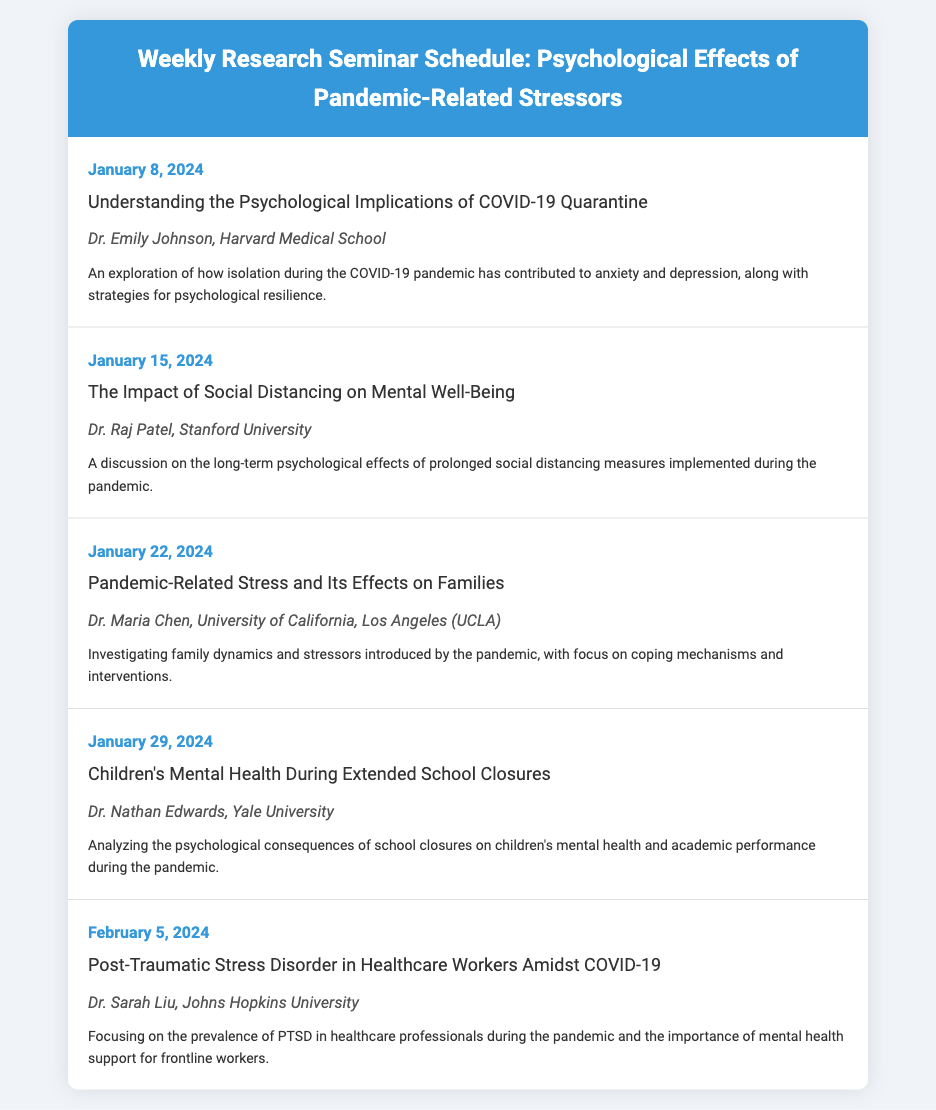What is the title of the seminar on January 15, 2024? The title of the seminar on January 15, 2024, is listed under the seminar topic section, which is "The Impact of Social Distancing on Mental Well-Being."
Answer: The Impact of Social Distancing on Mental Well-Being Who is the presenter for the seminar on January 22, 2024? The presenter for the January 22, 2024 seminar is mentioned in the seminar-presenter section, stated directly after the topic.
Answer: Dr. Maria Chen, University of California, Los Angeles (UCLA) What date is the seminar focused on children's mental health scheduled? The date for the seminar about children's mental health can be found at the start of its section, clearly labeled.
Answer: January 29, 2024 How many seminars are scheduled in January 2024? The total number of seminars can be counted from the list displayed for January 2024.
Answer: Four What mental health condition is discussed concerning healthcare workers on February 5, 2024? The specific mental health condition is described in the seminar description for that day, which addresses a particular issue faced by healthcare workers.
Answer: Post-Traumatic Stress Disorder 